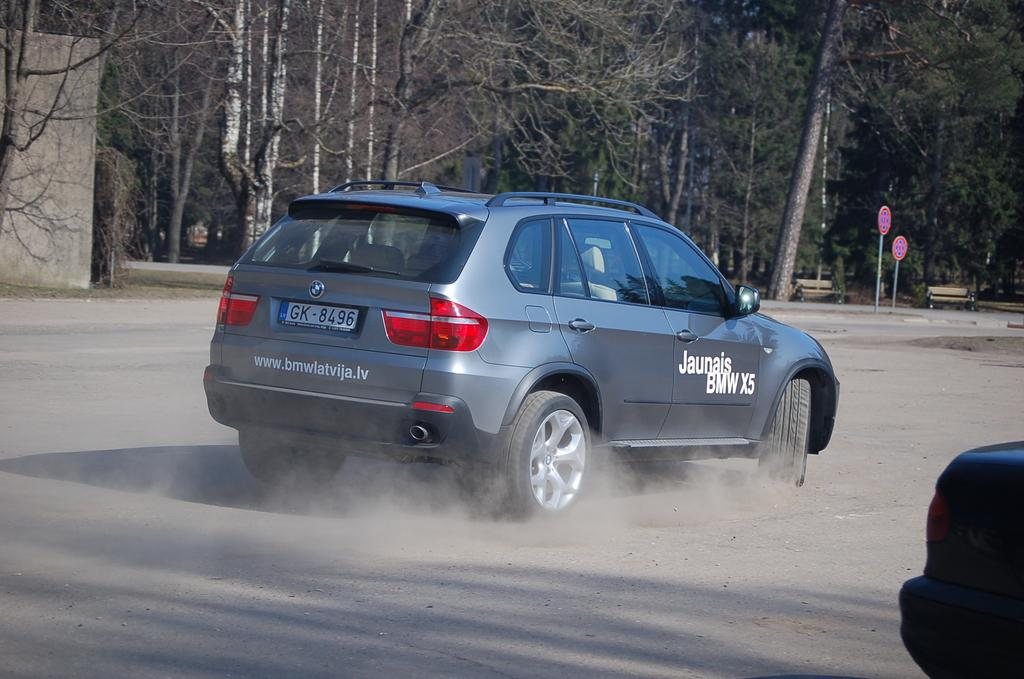<image>
Offer a succinct explanation of the picture presented. A grey car that is the brand bmw and says jaunais bmw on the side. 